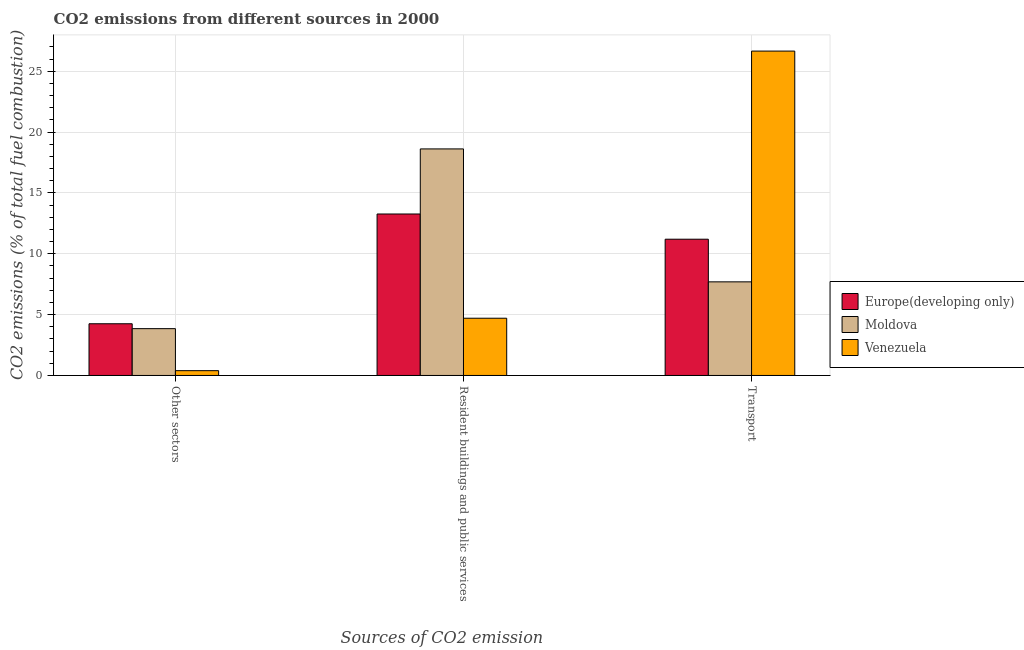How many different coloured bars are there?
Your response must be concise. 3. How many groups of bars are there?
Offer a very short reply. 3. Are the number of bars per tick equal to the number of legend labels?
Your response must be concise. Yes. Are the number of bars on each tick of the X-axis equal?
Give a very brief answer. Yes. What is the label of the 3rd group of bars from the left?
Your answer should be compact. Transport. What is the percentage of co2 emissions from resident buildings and public services in Moldova?
Provide a succinct answer. 18.62. Across all countries, what is the maximum percentage of co2 emissions from transport?
Ensure brevity in your answer.  26.65. Across all countries, what is the minimum percentage of co2 emissions from resident buildings and public services?
Make the answer very short. 4.7. In which country was the percentage of co2 emissions from resident buildings and public services maximum?
Your answer should be compact. Moldova. In which country was the percentage of co2 emissions from transport minimum?
Provide a short and direct response. Moldova. What is the total percentage of co2 emissions from other sectors in the graph?
Offer a terse response. 8.49. What is the difference between the percentage of co2 emissions from resident buildings and public services in Venezuela and that in Moldova?
Provide a succinct answer. -13.91. What is the difference between the percentage of co2 emissions from other sectors in Europe(developing only) and the percentage of co2 emissions from transport in Moldova?
Keep it short and to the point. -3.44. What is the average percentage of co2 emissions from other sectors per country?
Provide a short and direct response. 2.83. What is the difference between the percentage of co2 emissions from transport and percentage of co2 emissions from other sectors in Moldova?
Give a very brief answer. 3.85. What is the ratio of the percentage of co2 emissions from transport in Moldova to that in Europe(developing only)?
Keep it short and to the point. 0.69. What is the difference between the highest and the second highest percentage of co2 emissions from transport?
Offer a very short reply. 15.46. What is the difference between the highest and the lowest percentage of co2 emissions from resident buildings and public services?
Make the answer very short. 13.91. What does the 3rd bar from the left in Resident buildings and public services represents?
Ensure brevity in your answer.  Venezuela. What does the 2nd bar from the right in Other sectors represents?
Keep it short and to the point. Moldova. How many bars are there?
Provide a short and direct response. 9. Are all the bars in the graph horizontal?
Give a very brief answer. No. How many countries are there in the graph?
Provide a succinct answer. 3. What is the difference between two consecutive major ticks on the Y-axis?
Provide a short and direct response. 5. Are the values on the major ticks of Y-axis written in scientific E-notation?
Your answer should be compact. No. Does the graph contain any zero values?
Ensure brevity in your answer.  No. Does the graph contain grids?
Offer a very short reply. Yes. How many legend labels are there?
Offer a terse response. 3. What is the title of the graph?
Keep it short and to the point. CO2 emissions from different sources in 2000. Does "Yemen, Rep." appear as one of the legend labels in the graph?
Your response must be concise. No. What is the label or title of the X-axis?
Offer a terse response. Sources of CO2 emission. What is the label or title of the Y-axis?
Provide a short and direct response. CO2 emissions (% of total fuel combustion). What is the CO2 emissions (% of total fuel combustion) of Europe(developing only) in Other sectors?
Your answer should be compact. 4.25. What is the CO2 emissions (% of total fuel combustion) in Moldova in Other sectors?
Keep it short and to the point. 3.85. What is the CO2 emissions (% of total fuel combustion) in Venezuela in Other sectors?
Provide a short and direct response. 0.39. What is the CO2 emissions (% of total fuel combustion) of Europe(developing only) in Resident buildings and public services?
Offer a very short reply. 13.27. What is the CO2 emissions (% of total fuel combustion) of Moldova in Resident buildings and public services?
Offer a terse response. 18.62. What is the CO2 emissions (% of total fuel combustion) in Venezuela in Resident buildings and public services?
Your answer should be very brief. 4.7. What is the CO2 emissions (% of total fuel combustion) of Europe(developing only) in Transport?
Your answer should be very brief. 11.2. What is the CO2 emissions (% of total fuel combustion) of Moldova in Transport?
Provide a succinct answer. 7.69. What is the CO2 emissions (% of total fuel combustion) in Venezuela in Transport?
Provide a short and direct response. 26.65. Across all Sources of CO2 emission, what is the maximum CO2 emissions (% of total fuel combustion) in Europe(developing only)?
Provide a succinct answer. 13.27. Across all Sources of CO2 emission, what is the maximum CO2 emissions (% of total fuel combustion) of Moldova?
Offer a very short reply. 18.62. Across all Sources of CO2 emission, what is the maximum CO2 emissions (% of total fuel combustion) of Venezuela?
Provide a succinct answer. 26.65. Across all Sources of CO2 emission, what is the minimum CO2 emissions (% of total fuel combustion) in Europe(developing only)?
Your answer should be very brief. 4.25. Across all Sources of CO2 emission, what is the minimum CO2 emissions (% of total fuel combustion) in Moldova?
Make the answer very short. 3.85. Across all Sources of CO2 emission, what is the minimum CO2 emissions (% of total fuel combustion) of Venezuela?
Your response must be concise. 0.39. What is the total CO2 emissions (% of total fuel combustion) of Europe(developing only) in the graph?
Make the answer very short. 28.71. What is the total CO2 emissions (% of total fuel combustion) in Moldova in the graph?
Offer a very short reply. 30.15. What is the total CO2 emissions (% of total fuel combustion) in Venezuela in the graph?
Ensure brevity in your answer.  31.75. What is the difference between the CO2 emissions (% of total fuel combustion) in Europe(developing only) in Other sectors and that in Resident buildings and public services?
Make the answer very short. -9.02. What is the difference between the CO2 emissions (% of total fuel combustion) in Moldova in Other sectors and that in Resident buildings and public services?
Offer a terse response. -14.77. What is the difference between the CO2 emissions (% of total fuel combustion) in Venezuela in Other sectors and that in Resident buildings and public services?
Your answer should be compact. -4.31. What is the difference between the CO2 emissions (% of total fuel combustion) of Europe(developing only) in Other sectors and that in Transport?
Provide a succinct answer. -6.95. What is the difference between the CO2 emissions (% of total fuel combustion) in Moldova in Other sectors and that in Transport?
Offer a terse response. -3.85. What is the difference between the CO2 emissions (% of total fuel combustion) of Venezuela in Other sectors and that in Transport?
Offer a very short reply. -26.26. What is the difference between the CO2 emissions (% of total fuel combustion) of Europe(developing only) in Resident buildings and public services and that in Transport?
Your response must be concise. 2.07. What is the difference between the CO2 emissions (% of total fuel combustion) of Moldova in Resident buildings and public services and that in Transport?
Keep it short and to the point. 10.92. What is the difference between the CO2 emissions (% of total fuel combustion) in Venezuela in Resident buildings and public services and that in Transport?
Keep it short and to the point. -21.95. What is the difference between the CO2 emissions (% of total fuel combustion) of Europe(developing only) in Other sectors and the CO2 emissions (% of total fuel combustion) of Moldova in Resident buildings and public services?
Your answer should be very brief. -14.37. What is the difference between the CO2 emissions (% of total fuel combustion) of Europe(developing only) in Other sectors and the CO2 emissions (% of total fuel combustion) of Venezuela in Resident buildings and public services?
Your answer should be compact. -0.45. What is the difference between the CO2 emissions (% of total fuel combustion) in Moldova in Other sectors and the CO2 emissions (% of total fuel combustion) in Venezuela in Resident buildings and public services?
Your answer should be compact. -0.86. What is the difference between the CO2 emissions (% of total fuel combustion) in Europe(developing only) in Other sectors and the CO2 emissions (% of total fuel combustion) in Moldova in Transport?
Give a very brief answer. -3.44. What is the difference between the CO2 emissions (% of total fuel combustion) of Europe(developing only) in Other sectors and the CO2 emissions (% of total fuel combustion) of Venezuela in Transport?
Your answer should be very brief. -22.4. What is the difference between the CO2 emissions (% of total fuel combustion) in Moldova in Other sectors and the CO2 emissions (% of total fuel combustion) in Venezuela in Transport?
Keep it short and to the point. -22.81. What is the difference between the CO2 emissions (% of total fuel combustion) in Europe(developing only) in Resident buildings and public services and the CO2 emissions (% of total fuel combustion) in Moldova in Transport?
Your answer should be compact. 5.58. What is the difference between the CO2 emissions (% of total fuel combustion) of Europe(developing only) in Resident buildings and public services and the CO2 emissions (% of total fuel combustion) of Venezuela in Transport?
Your answer should be compact. -13.39. What is the difference between the CO2 emissions (% of total fuel combustion) of Moldova in Resident buildings and public services and the CO2 emissions (% of total fuel combustion) of Venezuela in Transport?
Keep it short and to the point. -8.04. What is the average CO2 emissions (% of total fuel combustion) of Europe(developing only) per Sources of CO2 emission?
Make the answer very short. 9.57. What is the average CO2 emissions (% of total fuel combustion) of Moldova per Sources of CO2 emission?
Keep it short and to the point. 10.05. What is the average CO2 emissions (% of total fuel combustion) of Venezuela per Sources of CO2 emission?
Ensure brevity in your answer.  10.58. What is the difference between the CO2 emissions (% of total fuel combustion) in Europe(developing only) and CO2 emissions (% of total fuel combustion) in Moldova in Other sectors?
Provide a succinct answer. 0.4. What is the difference between the CO2 emissions (% of total fuel combustion) in Europe(developing only) and CO2 emissions (% of total fuel combustion) in Venezuela in Other sectors?
Give a very brief answer. 3.85. What is the difference between the CO2 emissions (% of total fuel combustion) of Moldova and CO2 emissions (% of total fuel combustion) of Venezuela in Other sectors?
Your answer should be very brief. 3.45. What is the difference between the CO2 emissions (% of total fuel combustion) of Europe(developing only) and CO2 emissions (% of total fuel combustion) of Moldova in Resident buildings and public services?
Your response must be concise. -5.35. What is the difference between the CO2 emissions (% of total fuel combustion) in Europe(developing only) and CO2 emissions (% of total fuel combustion) in Venezuela in Resident buildings and public services?
Provide a short and direct response. 8.56. What is the difference between the CO2 emissions (% of total fuel combustion) in Moldova and CO2 emissions (% of total fuel combustion) in Venezuela in Resident buildings and public services?
Give a very brief answer. 13.91. What is the difference between the CO2 emissions (% of total fuel combustion) of Europe(developing only) and CO2 emissions (% of total fuel combustion) of Moldova in Transport?
Your answer should be compact. 3.5. What is the difference between the CO2 emissions (% of total fuel combustion) in Europe(developing only) and CO2 emissions (% of total fuel combustion) in Venezuela in Transport?
Make the answer very short. -15.46. What is the difference between the CO2 emissions (% of total fuel combustion) in Moldova and CO2 emissions (% of total fuel combustion) in Venezuela in Transport?
Provide a short and direct response. -18.96. What is the ratio of the CO2 emissions (% of total fuel combustion) of Europe(developing only) in Other sectors to that in Resident buildings and public services?
Your answer should be very brief. 0.32. What is the ratio of the CO2 emissions (% of total fuel combustion) in Moldova in Other sectors to that in Resident buildings and public services?
Offer a terse response. 0.21. What is the ratio of the CO2 emissions (% of total fuel combustion) in Venezuela in Other sectors to that in Resident buildings and public services?
Keep it short and to the point. 0.08. What is the ratio of the CO2 emissions (% of total fuel combustion) of Europe(developing only) in Other sectors to that in Transport?
Make the answer very short. 0.38. What is the ratio of the CO2 emissions (% of total fuel combustion) in Moldova in Other sectors to that in Transport?
Your answer should be compact. 0.5. What is the ratio of the CO2 emissions (% of total fuel combustion) of Venezuela in Other sectors to that in Transport?
Offer a terse response. 0.01. What is the ratio of the CO2 emissions (% of total fuel combustion) of Europe(developing only) in Resident buildings and public services to that in Transport?
Give a very brief answer. 1.19. What is the ratio of the CO2 emissions (% of total fuel combustion) of Moldova in Resident buildings and public services to that in Transport?
Make the answer very short. 2.42. What is the ratio of the CO2 emissions (% of total fuel combustion) of Venezuela in Resident buildings and public services to that in Transport?
Provide a short and direct response. 0.18. What is the difference between the highest and the second highest CO2 emissions (% of total fuel combustion) in Europe(developing only)?
Ensure brevity in your answer.  2.07. What is the difference between the highest and the second highest CO2 emissions (% of total fuel combustion) in Moldova?
Keep it short and to the point. 10.92. What is the difference between the highest and the second highest CO2 emissions (% of total fuel combustion) in Venezuela?
Keep it short and to the point. 21.95. What is the difference between the highest and the lowest CO2 emissions (% of total fuel combustion) of Europe(developing only)?
Give a very brief answer. 9.02. What is the difference between the highest and the lowest CO2 emissions (% of total fuel combustion) in Moldova?
Offer a very short reply. 14.77. What is the difference between the highest and the lowest CO2 emissions (% of total fuel combustion) of Venezuela?
Make the answer very short. 26.26. 